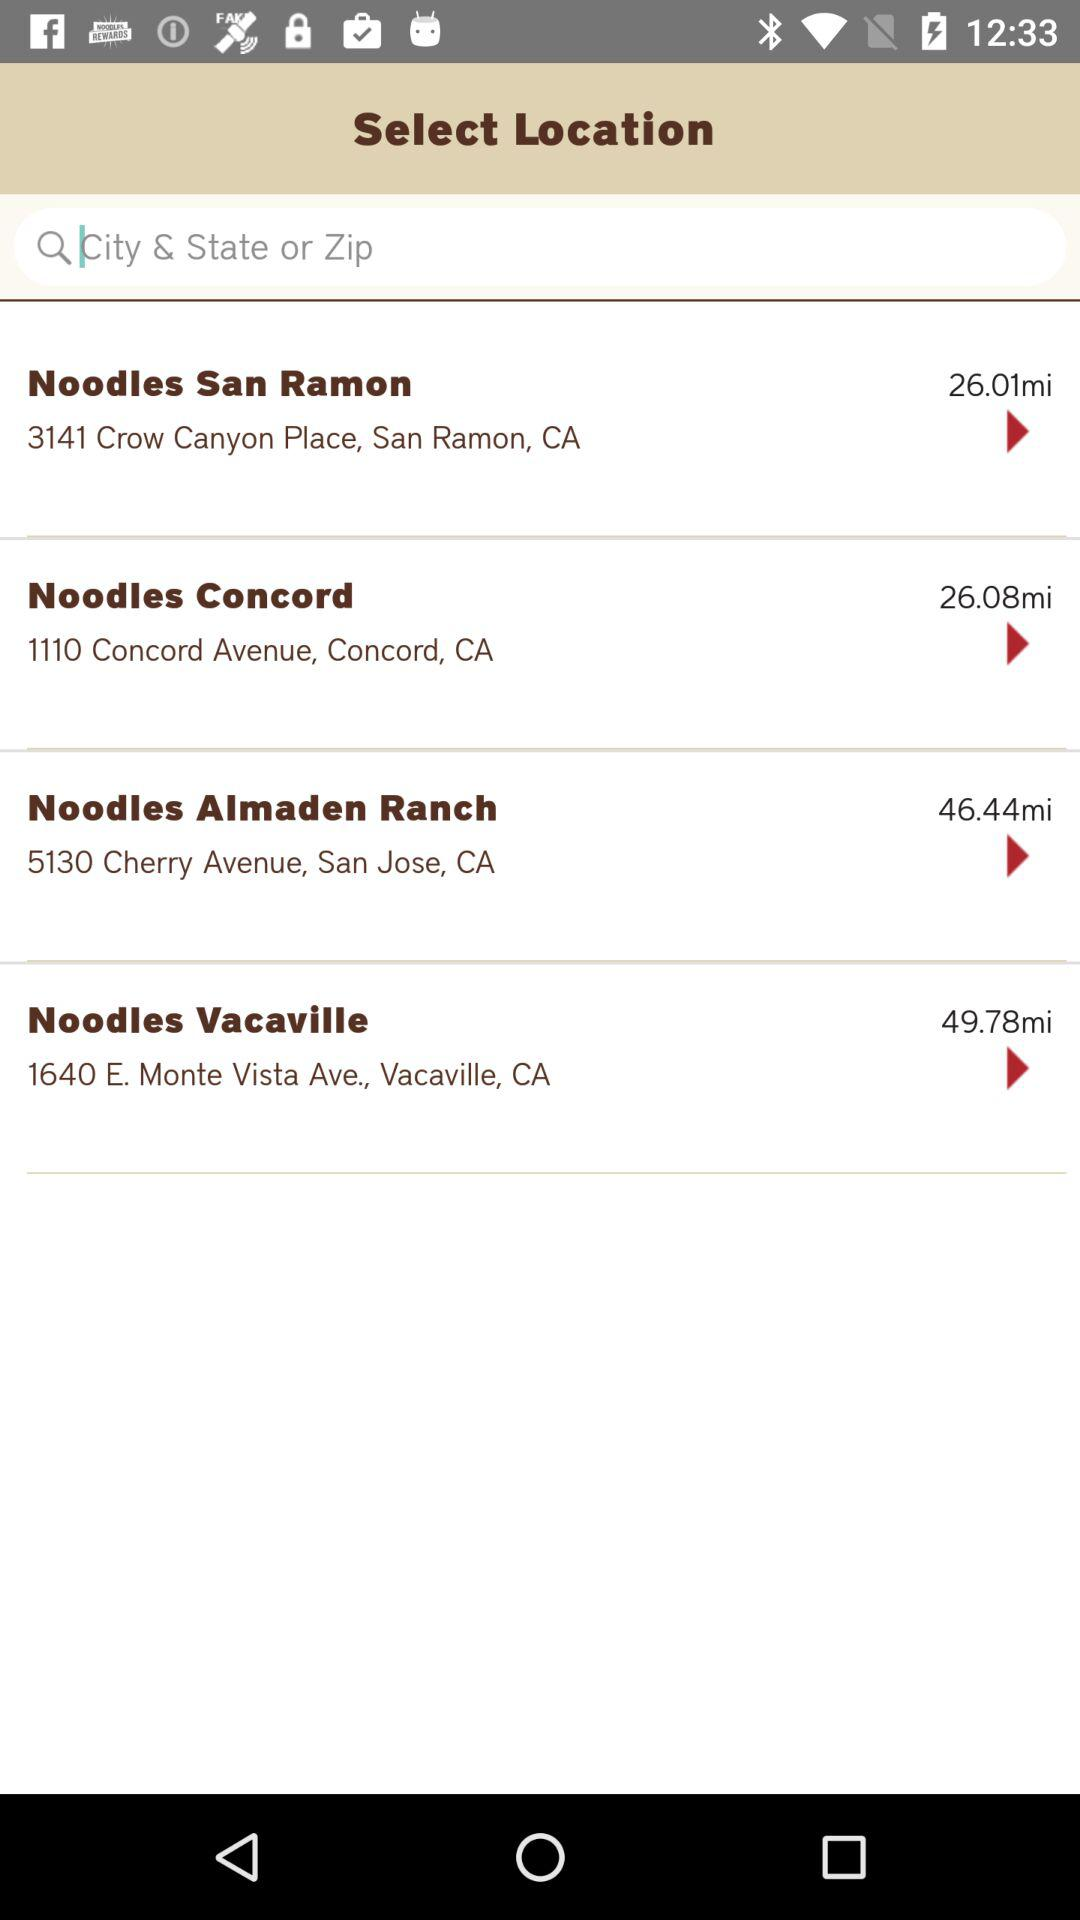What is the address of Noodles Vacaville? The address of Noodles Vacaville is 1640 E. Monte Vista Ave., Vacaville, CA. 